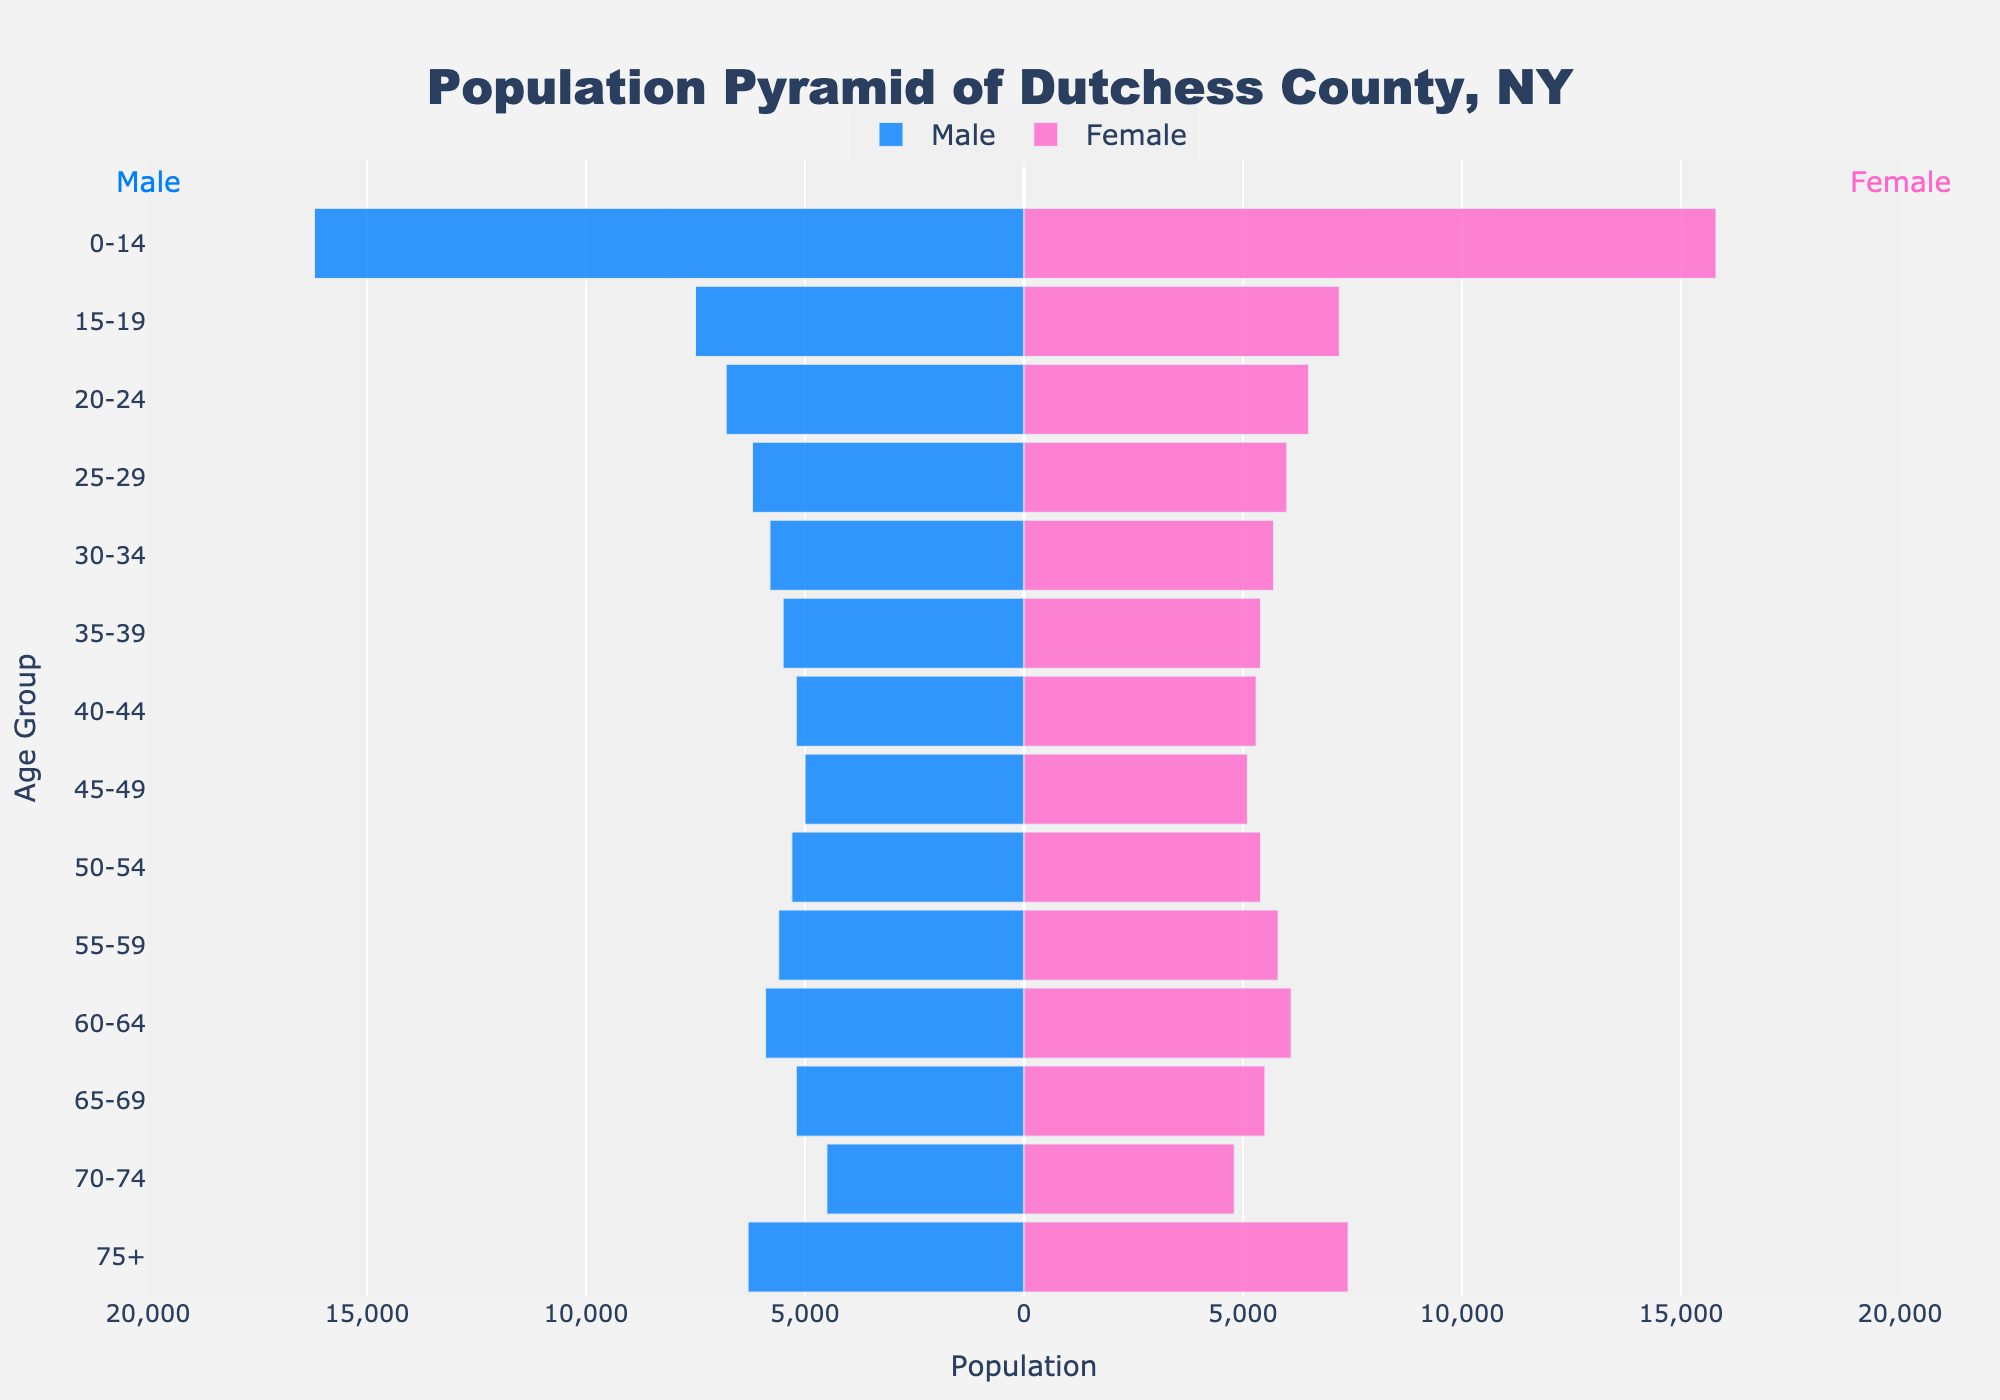What is the age range that has the highest male population? Look at the length of the blue bars on the left side. The longest blue bar represents the age range with the highest male population.
Answer: 0-14 Which gender has more people in the age group 55-59? Compare the lengths of the blue and pink bars for the age group 55-59. The longer bar indicates the gender with more people.
Answer: Female What is the educational attainment level for individuals in the age group 35-39? Check the annotations on the right side of the figure for the age group 35-39. The annotation beside this age group indicates the educational attainment level.
Answer: Bachelor's Degree Compare the populations of males and females in the age group 75+. Which gender has a higher population, and by how much? Look at the lengths of the blue and pink bars for the age group 75+. Subtract the length of the blue bar from the pink bar to find the difference.
Answer: Female, by 1100 What is the combined population for males and females in the age group 15-19? Add the populations represented by both the blue and pink bars for the age group 15-19.
Answer: 14700 Which age group has the narrowest gender gap, and what is the educational attainment level of that age group? Calculate the difference between the lengths of blue and pink bars for each age group. The smallest difference indicates the narrowest gender gap. Check the annotation for the educational attainment level.
Answer: 40-44, Master's Degree What are the age groups where the female population is greater than the male population? Compare the lengths of the blue and pink bars for each age group. List the age groups where the pink bar is longer.
Answer: 50-54, 55-59, 60-64, 65-69, 70-74, 75+ What is the average population for females aged 30-39? Add the populations represented by the pink bars for ages 30-34 and 35-39, then divide by the number of age groups (2).
Answer: 5550 In which age group is the educational attainment labeled as 'High School (Incomplete)'? Check the annotations on the right side of the figure to find the 'High School (Incomplete)' label. The corresponding age group is displayed beside it.
Answer: 15-19 What is the total population of Dutchess County, NY for the age group 0-14? Sum the populations of males and females in the age group 0-14.
Answer: 32000 